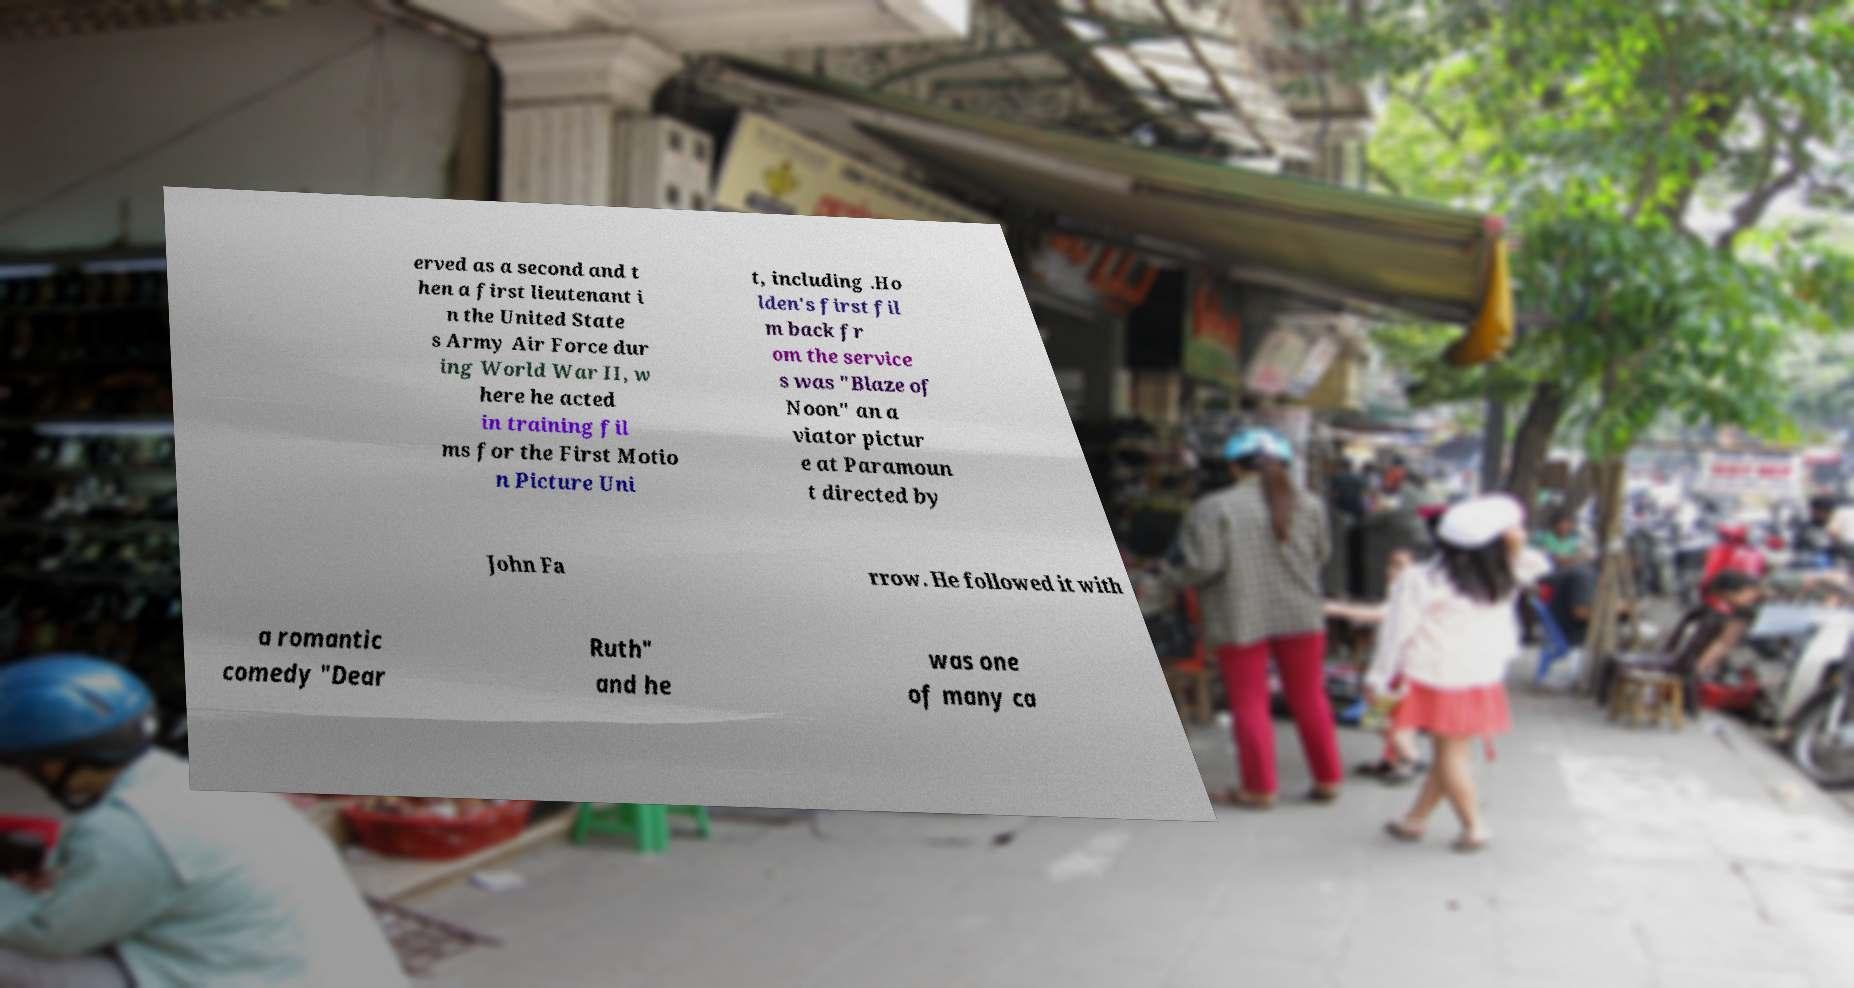For documentation purposes, I need the text within this image transcribed. Could you provide that? erved as a second and t hen a first lieutenant i n the United State s Army Air Force dur ing World War II, w here he acted in training fil ms for the First Motio n Picture Uni t, including .Ho lden's first fil m back fr om the service s was "Blaze of Noon" an a viator pictur e at Paramoun t directed by John Fa rrow. He followed it with a romantic comedy "Dear Ruth" and he was one of many ca 